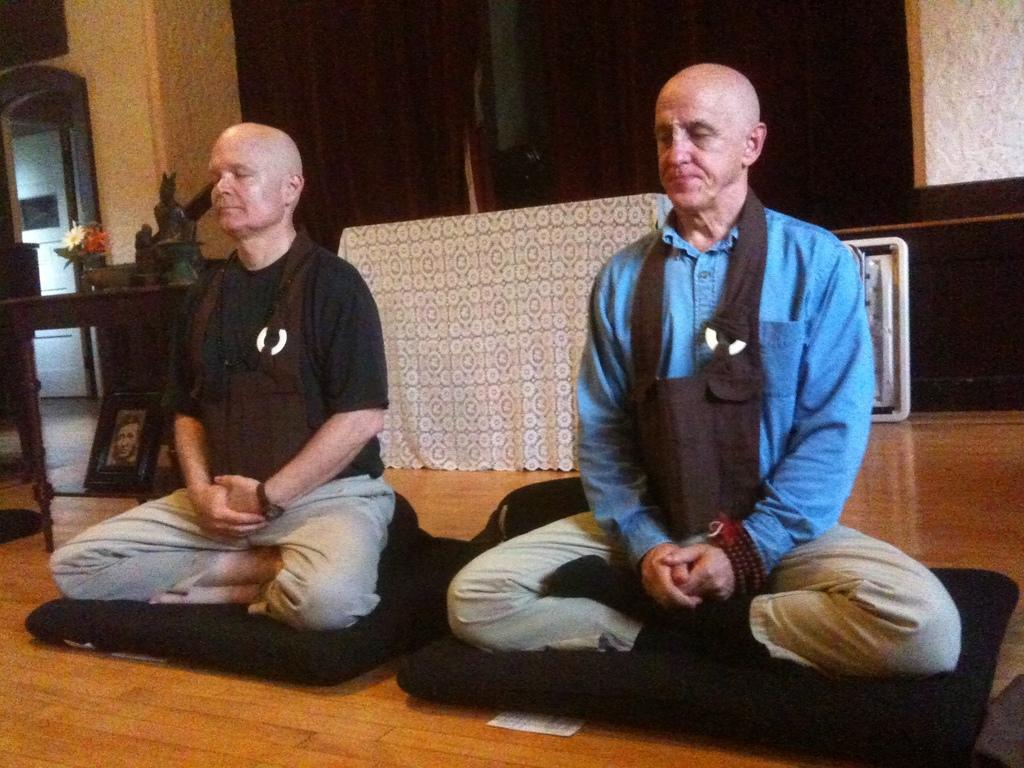How many people are present in the image? There are two men sitting in the image. What can be seen in the background of the image? There is a photo frame and a plant in the background of the image. What type of pest can be seen crawling on the men in the image? There are no pests visible in the image; it only shows two men sitting and a background with a photo frame and a plant. 